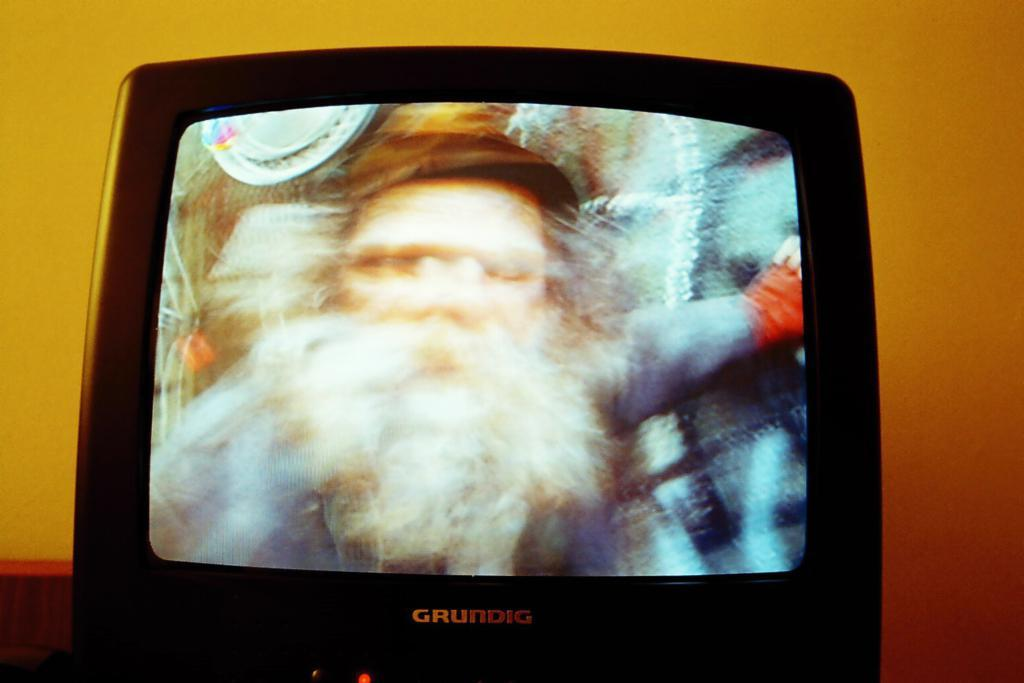What electronic device is visible in the image? There is a television in the image. What can be seen behind the television in the image? There is a wall in the background of the image. Is there a veil covering the television in the image? No, there is no veil present in the image. 